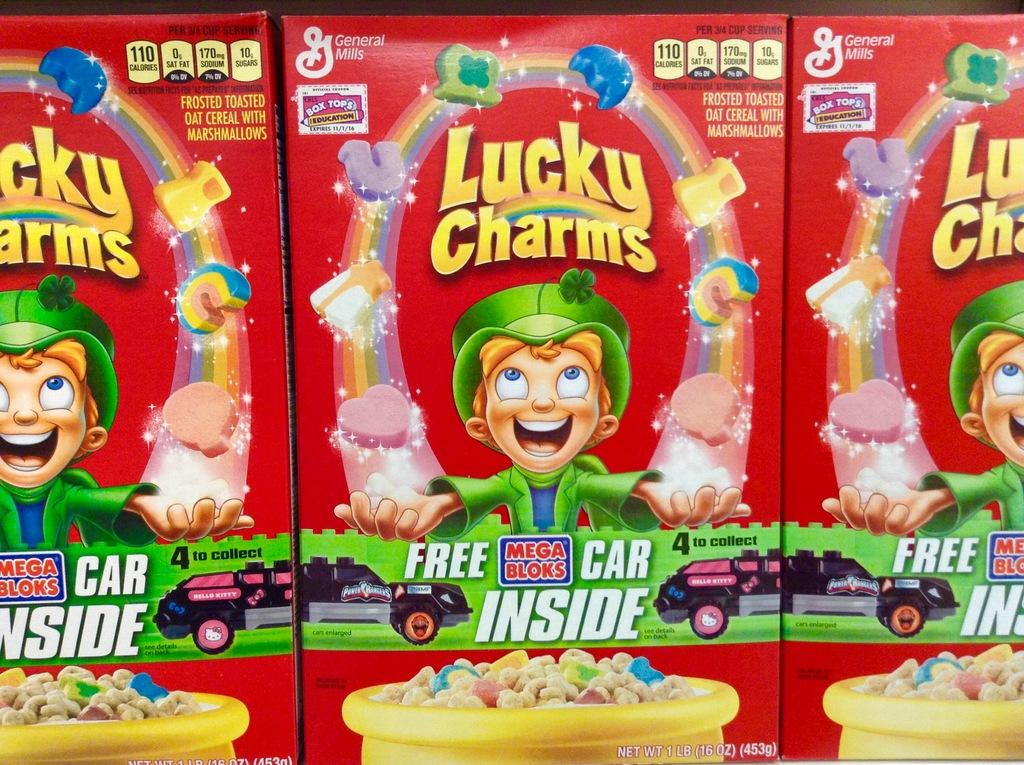What objects are present in the image that are box-shaped? There are boxes in the image. What color are the boxes? The boxes are red in color. What is depicted on the boxes? There is a cartoon character on the boxes. What can be read or seen in the form of text in the image? There are words visible in the image. What type of vehicle is in the image? There is a car in the image. What is the color of the bowl in the image? There is a yellow color bowl in the image. What is inside the bowl? There is food on the bowl. Where are the fairies hiding in the image? There are no fairies present in the image. What type of container is used to hold arrows in the image? There is no container for arrows, nor any arrows, present in the image. 